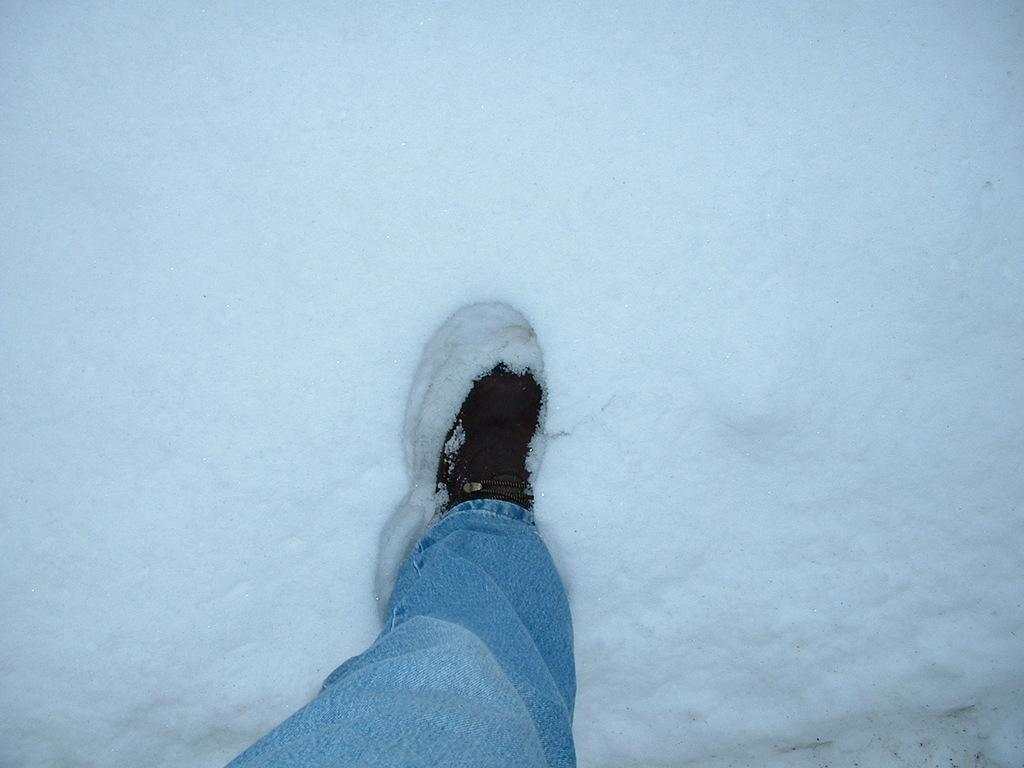What part of the person's body is visible in the image? There is a person's leg in the image. What color are the pants the person is wearing? The person is wearing blue pants. What type of footwear is the person wearing? The person is wearing a shoe. What is the weather condition in the image? There is snow all over the image. Who is the creator of the snow in the image? The image does not provide information about the creator of the snow; it simply shows snow as the weather condition. 